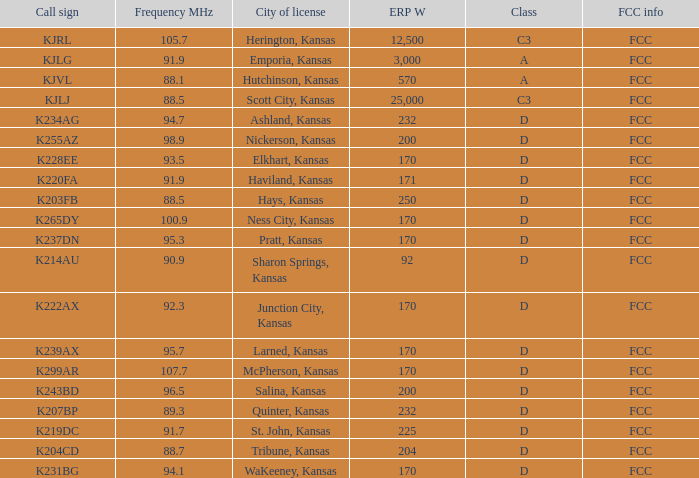Frequency MHz smaller than 95.3, and a Call sign of k234ag is what class? D. 